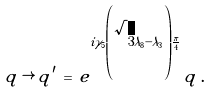Convert formula to latex. <formula><loc_0><loc_0><loc_500><loc_500>q \, \rightarrow \, q ^ { \prime } \, = \, e ^ { i \gamma _ { 5 } \left ( \sqrt { 3 } \lambda _ { 8 } - \lambda _ { 3 } \right ) \frac { \pi } { 4 } } \, q \, .</formula> 